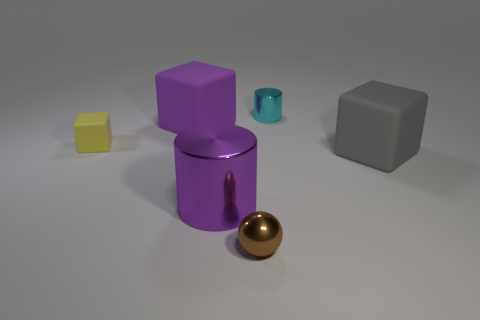Subtract all big gray rubber blocks. How many blocks are left? 2 Add 3 large purple rubber blocks. How many objects exist? 9 Subtract all gray blocks. How many blocks are left? 2 Subtract 2 cubes. How many cubes are left? 1 Subtract all blue cubes. Subtract all brown cylinders. How many cubes are left? 3 Subtract all cylinders. How many objects are left? 4 Subtract all tiny metallic spheres. Subtract all tiny cyan cylinders. How many objects are left? 4 Add 5 small metal spheres. How many small metal spheres are left? 6 Add 5 small yellow rubber objects. How many small yellow rubber objects exist? 6 Subtract 0 brown cylinders. How many objects are left? 6 